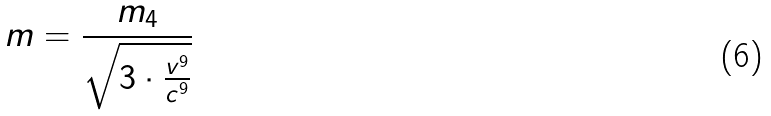Convert formula to latex. <formula><loc_0><loc_0><loc_500><loc_500>m = \frac { m _ { 4 } } { \sqrt { 3 \cdot \frac { v ^ { 9 } } { c ^ { 9 } } } }</formula> 